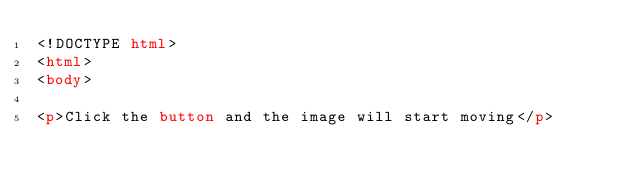<code> <loc_0><loc_0><loc_500><loc_500><_HTML_><!DOCTYPE html>
<html>
<body>

<p>Click the button and the image will start moving</p></code> 